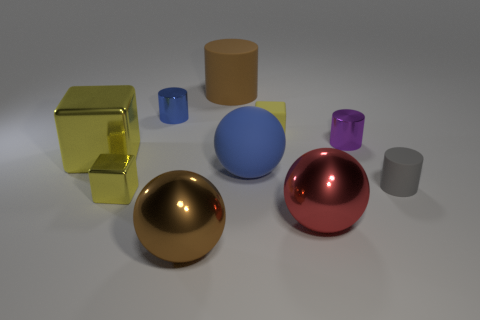Subtract 2 cylinders. How many cylinders are left? 2 Subtract all gray cylinders. How many cylinders are left? 3 Subtract all large brown matte cylinders. How many cylinders are left? 3 Subtract all gray blocks. Subtract all yellow cylinders. How many blocks are left? 3 Subtract all spheres. How many objects are left? 7 Add 9 brown rubber cylinders. How many brown rubber cylinders are left? 10 Add 2 big rubber cylinders. How many big rubber cylinders exist? 3 Subtract 1 gray cylinders. How many objects are left? 9 Subtract all big gray rubber things. Subtract all yellow blocks. How many objects are left? 7 